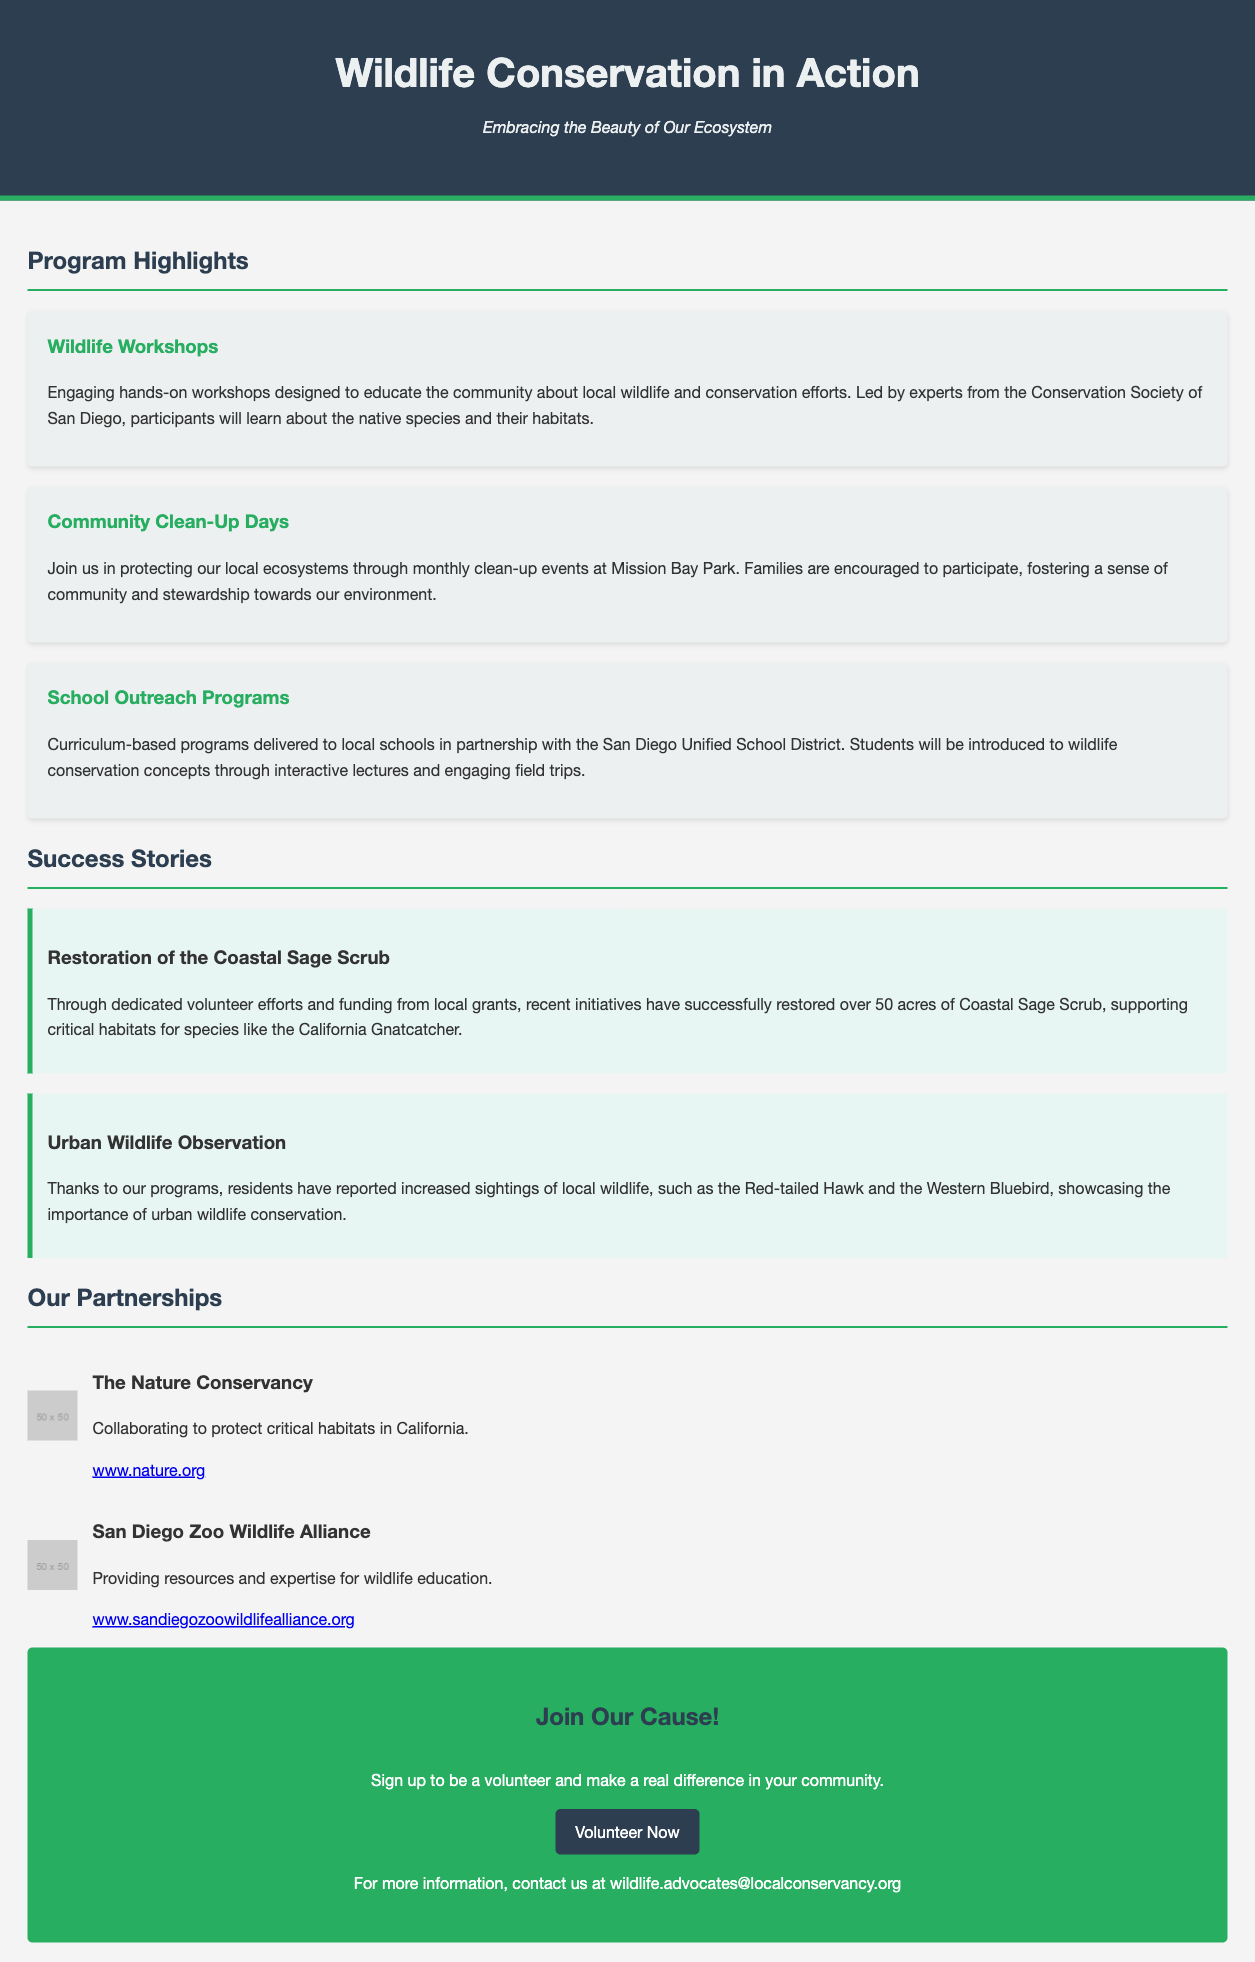what is the title of the document? The title of the document is indicated in the header section, presenting the main theme of the content.
Answer: Wildlife Conservation in Action who leads the Wildlife Workshops? The document specifies the organization responsible for leading the workshops.
Answer: Conservation Society of San Diego what is the purpose of Community Clean-Up Days? The document describes the objective of these events, which is to engage the community in environmental protection.
Answer: Protecting local ecosystems how many acres of Coastal Sage Scrub have been restored? The success story mentions the specific area that has been restored through conservation efforts.
Answer: 50 acres name one of the local wildlife species mentioned in the document. The success story highlights a specific species that benefits from conservation initiatives.
Answer: California Gnatcatcher which organization collaborates to protect critical habitats in California? The partnerships section names a specific organization involved in habitat protection efforts.
Answer: The Nature Conservancy how can people get more information about volunteering? The call-to-action section provides a way for people to contact the organization for more details.
Answer: Contact us at wildlife.advocates@localconservancy.org what is the main focus of the School Outreach Programs? The document explains the goal of these programs as part of their educational approach.
Answer: Wildlife conservation concepts 